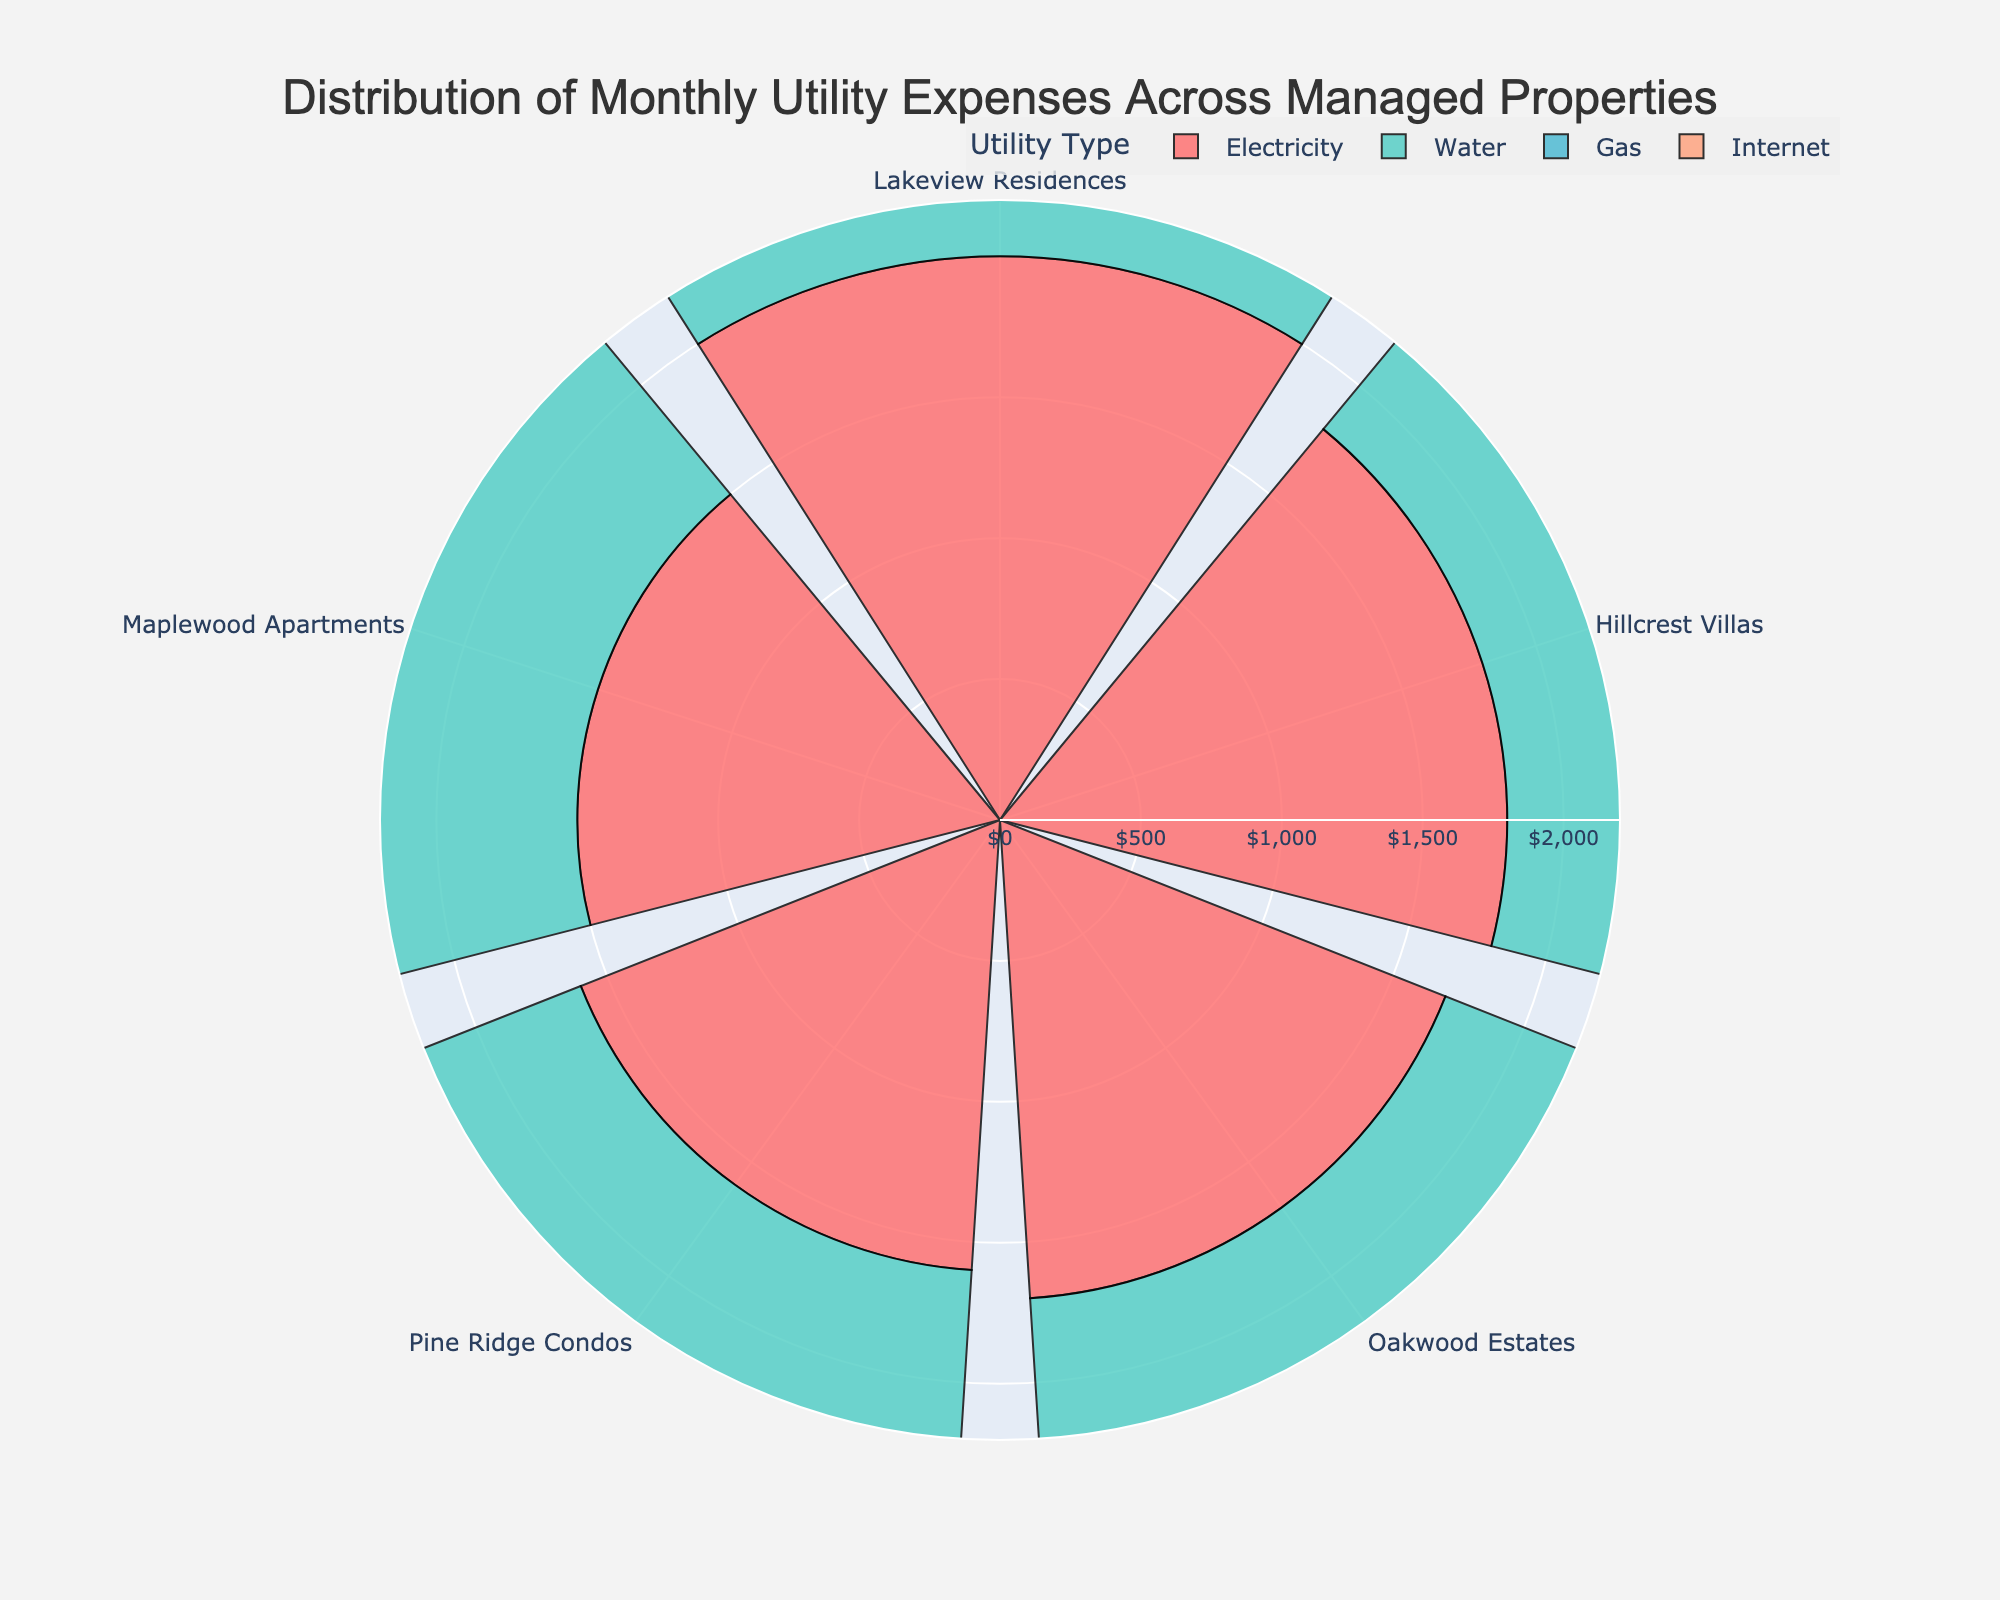How many managed properties are displayed in the rose chart? The chart displays each managed property as a segment in the polar plot. By counting the segments labeled with property names, we can tally the total number of properties shown.
Answer: 5 Which utility type has the smallest total expenses across all properties? To find the smallest total expense, sum the expenses for each utility type across all properties and compare them.
Answer: Internet Which property has the highest total monthly utility expenses? By observing the length of the bars representing total expenses for each property, we can see which property has the longest bar, indicating the highest total expenses.
Answer: Lakeview Residences Compare the gas expenses between Hillcrest Villas and Maplewood Apartments. Which property spends more? Observe the bars representing gas expenses for Hillcrest Villas and Maplewood Apartments. The property with the longer bar spends more on gas.
Answer: Hillcrest Villas Which property has the highest water expenses? Look for the segment with the longest bar in the water expense color. The longest bar indicates the highest water expense.
Answer: Lakeview Residences What is the difference in electricity expenses between Oakwood Estates and Pine Ridge Condos? Refer to the bar lengths for electricity expenses of both properties. Subtract the expense value of Pine Ridge Condos from Oakwood Estates' expense value.
Answer: 100 USD What's the average expense on electricity across all properties? Sum the electricity expenses for all properties and divide by the number of properties.
Answer: 1720 USD Are there any properties with the same total expenses for internet? Check the bar lengths for internet expenses across all properties and compare. If any bars have the same length, those properties have the same internet expenses.
Answer: Yes Which utility type varies the most in terms of expenses across different properties? Compare the range of bar lengths for each utility type. The utility type with the widest range of bar lengths has the most variation in expenses.
Answer: Electricity How do the water expenses in Maplewood Apartments compare to those in Oakwood Estates? Compare the bar lengths for water expenses of Maplewood Apartments and Oakwood Estates. Identify which property has a longer bar.
Answer: Oakwood Estates spends more 